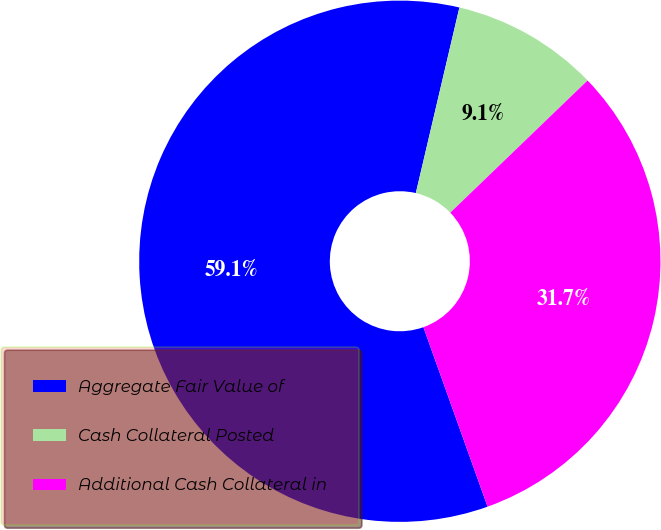Convert chart to OTSL. <chart><loc_0><loc_0><loc_500><loc_500><pie_chart><fcel>Aggregate Fair Value of<fcel>Cash Collateral Posted<fcel>Additional Cash Collateral in<nl><fcel>59.13%<fcel>9.13%<fcel>31.73%<nl></chart> 